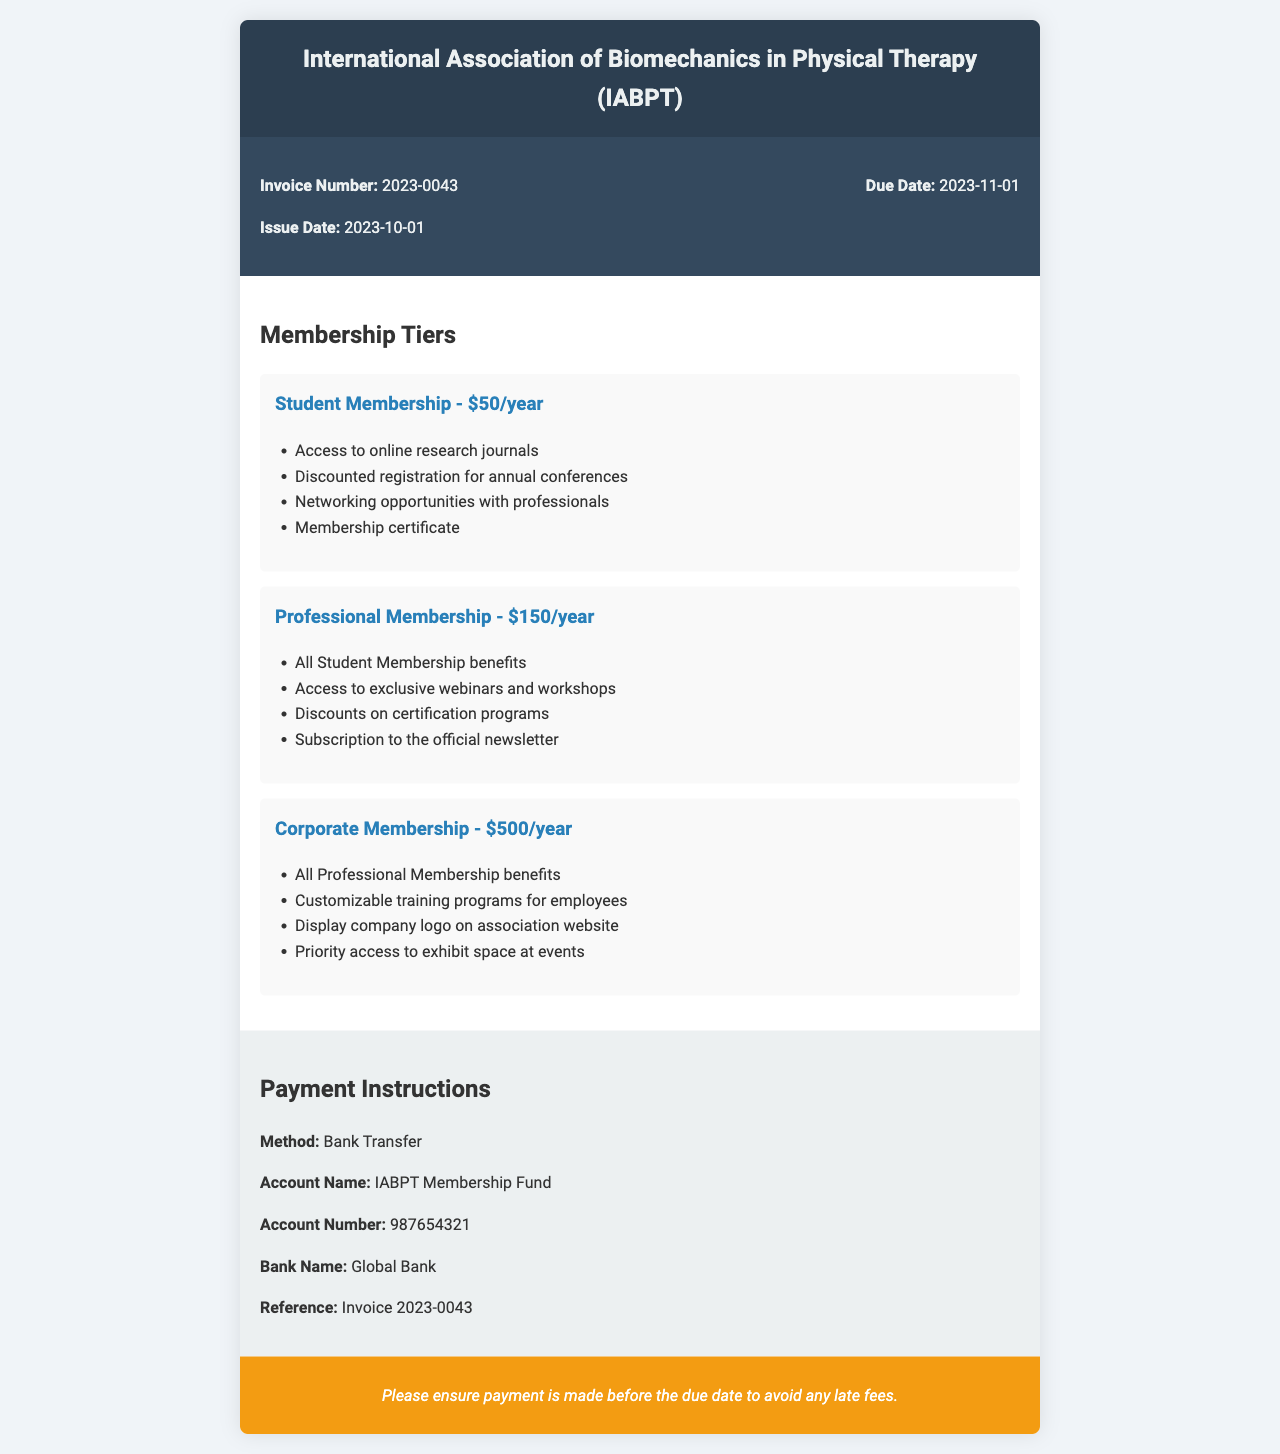What is the invoice number? The invoice number is explicitly mentioned in the document details section.
Answer: 2023-0043 What is the issue date of the invoice? The issue date is stated in the invoice details section.
Answer: 2023-10-01 What is the due date for the payment? The due date is outlined in the invoice details section and is crucial for payment planning.
Answer: 2023-11-01 What is the cost of Professional Membership? The cost is specified under the Professional Membership tier in the membership tiers section.
Answer: $150/year What are the benefits included in Corporate Membership? The benefits for Corporate Membership are listed under the respective tier in the document.
Answer: All Professional Membership benefits, Customizable training programs for employees, Display company logo on association website, Priority access to exhibit space at events What payment method is accepted? The accepted payment method is detailed in the payment instructions section.
Answer: Bank Transfer Who is the account name for the payment? The account name is mentioned in the payment instructions for clarity on where to send the funds.
Answer: IABPT Membership Fund What is the last date to ensure payment is made? The last date to avoid late fees is clearly indicated in the notes section.
Answer: 2023-11-01 What type of document is this? The purpose of the document is confirmed by its title and structure, which is characteristic of an invoice.
Answer: Invoice 